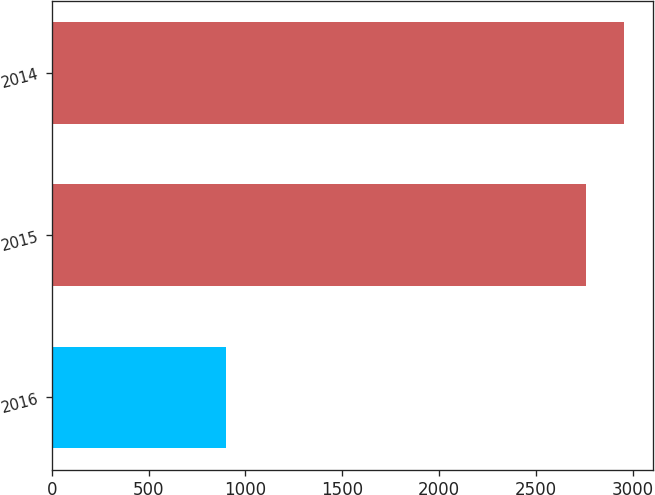<chart> <loc_0><loc_0><loc_500><loc_500><bar_chart><fcel>2016<fcel>2015<fcel>2014<nl><fcel>902<fcel>2759<fcel>2956.9<nl></chart> 